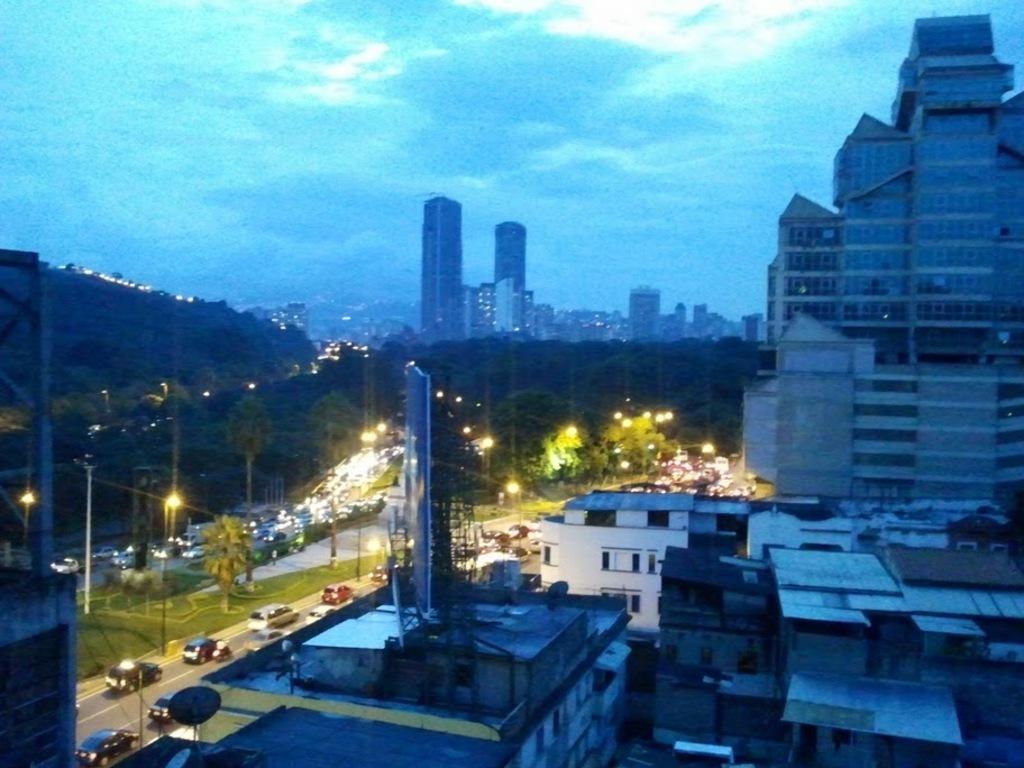Could you give a brief overview of what you see in this image? In this image I can see buildings, houses, trees, light poles, mountains and vehicles on the road. At the top I can see the blue sky. This image is taken may be during night. 